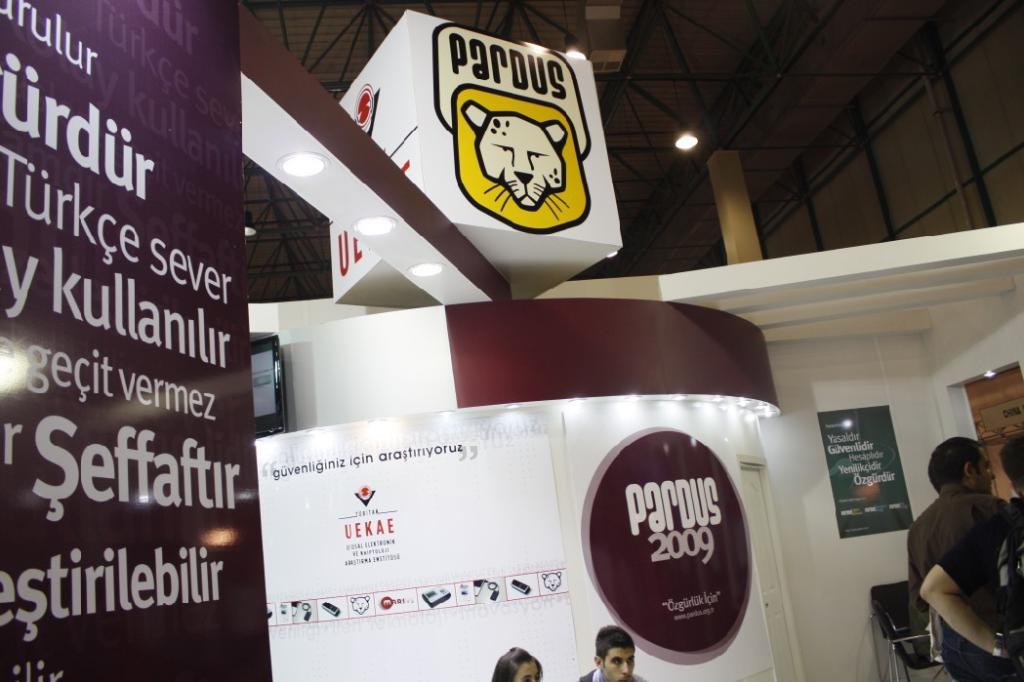What year is shown in the picture?
Give a very brief answer. 2009. Where are they?
Your response must be concise. Unanswerable. 